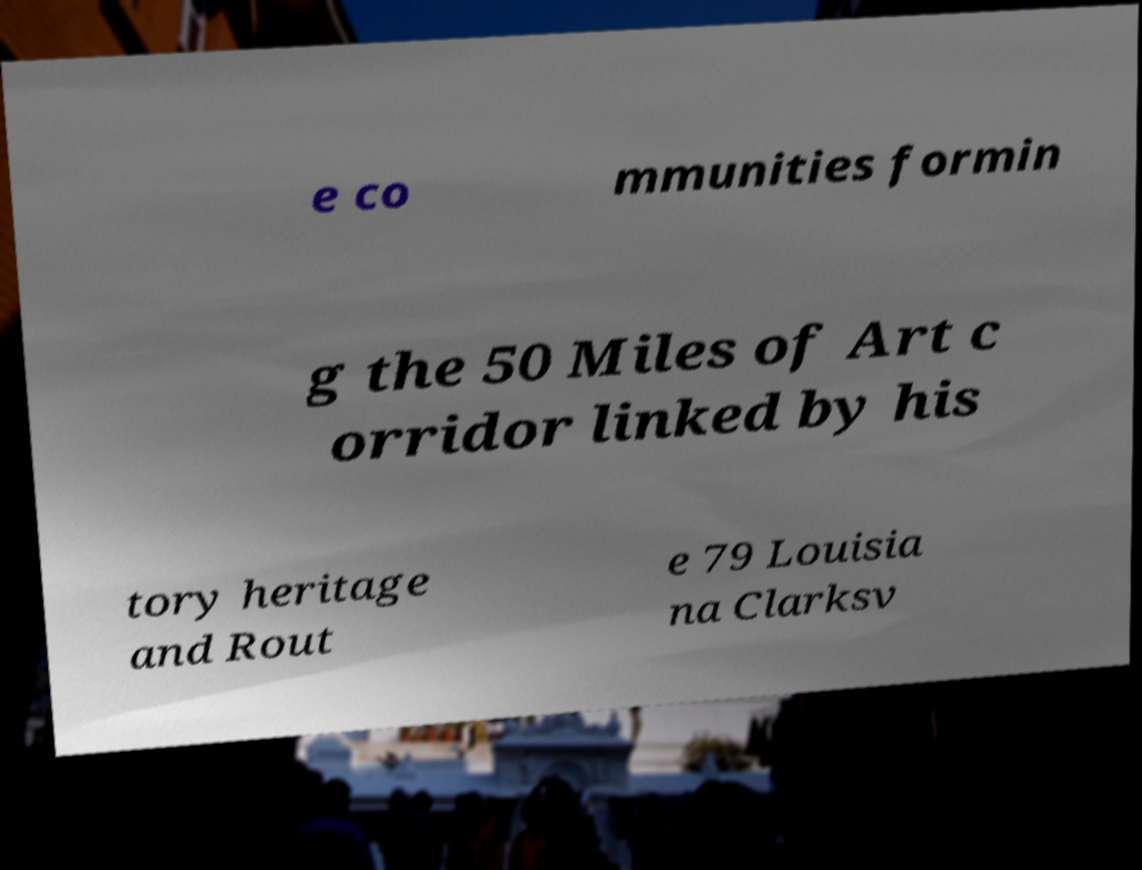I need the written content from this picture converted into text. Can you do that? e co mmunities formin g the 50 Miles of Art c orridor linked by his tory heritage and Rout e 79 Louisia na Clarksv 